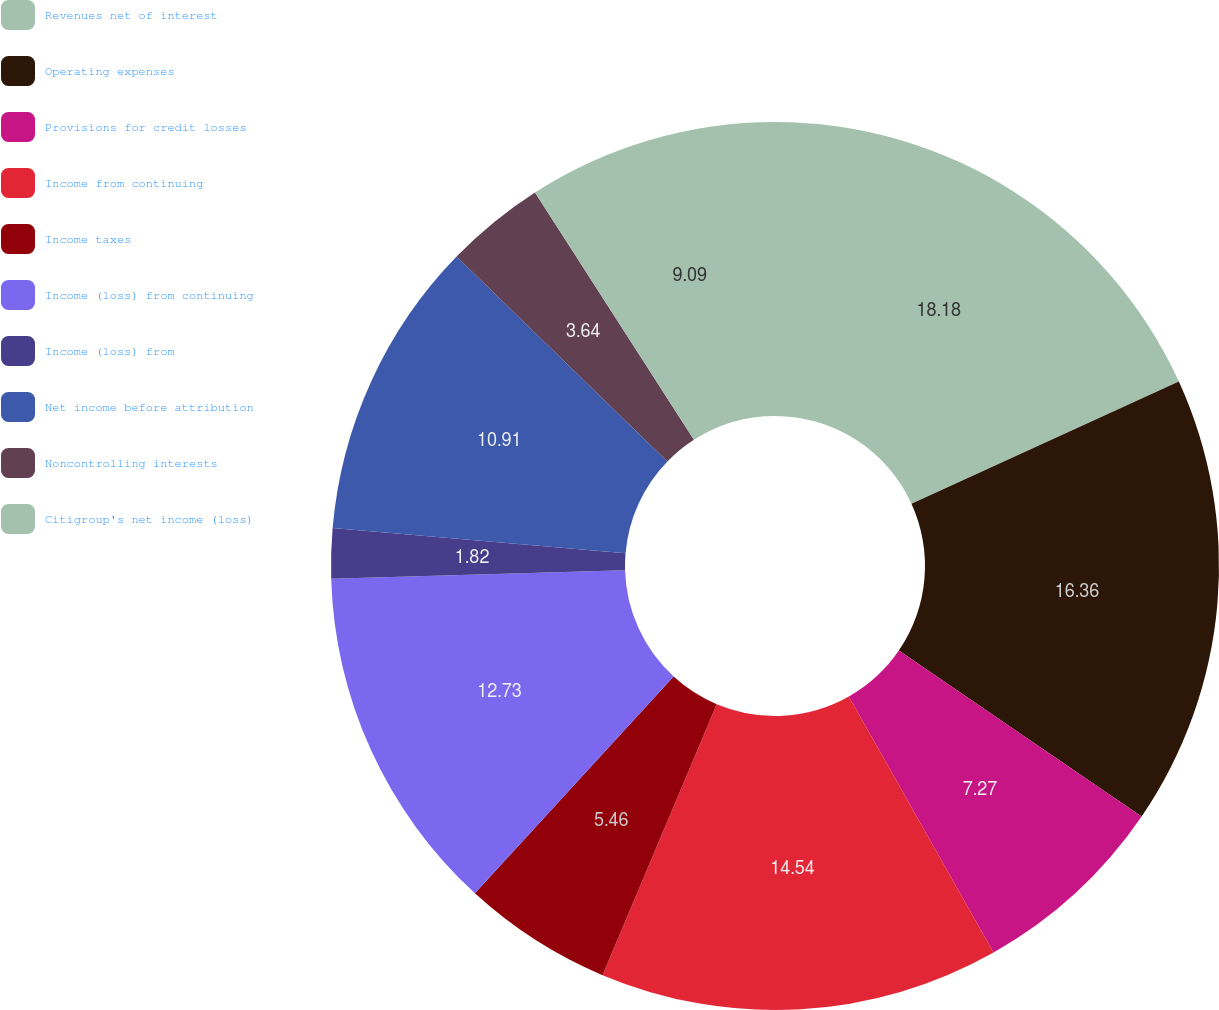Convert chart to OTSL. <chart><loc_0><loc_0><loc_500><loc_500><pie_chart><fcel>Revenues net of interest<fcel>Operating expenses<fcel>Provisions for credit losses<fcel>Income from continuing<fcel>Income taxes<fcel>Income (loss) from continuing<fcel>Income (loss) from<fcel>Net income before attribution<fcel>Noncontrolling interests<fcel>Citigroup's net income (loss)<nl><fcel>18.18%<fcel>16.36%<fcel>7.27%<fcel>14.54%<fcel>5.46%<fcel>12.73%<fcel>1.82%<fcel>10.91%<fcel>3.64%<fcel>9.09%<nl></chart> 